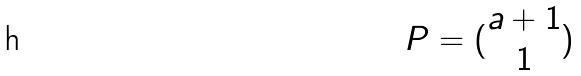Convert formula to latex. <formula><loc_0><loc_0><loc_500><loc_500>P = ( \begin{matrix} a + 1 \\ 1 \\ \end{matrix} )</formula> 